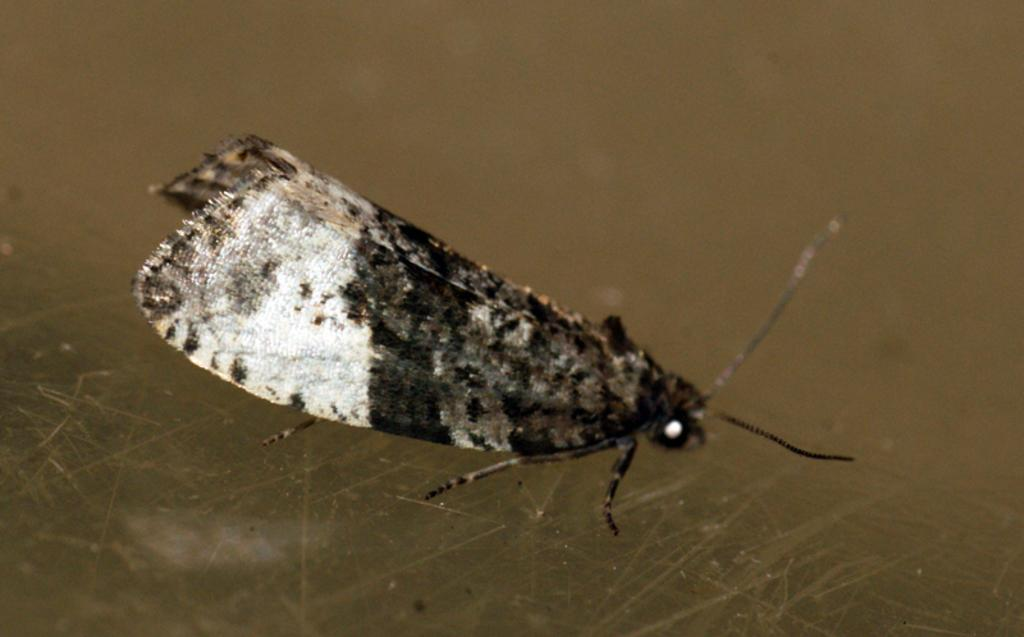What type of creature can be seen in the image? There is an insect in the image. What type of health advice can be found in the image? There is no health advice present in the image, as it only features an insect. 